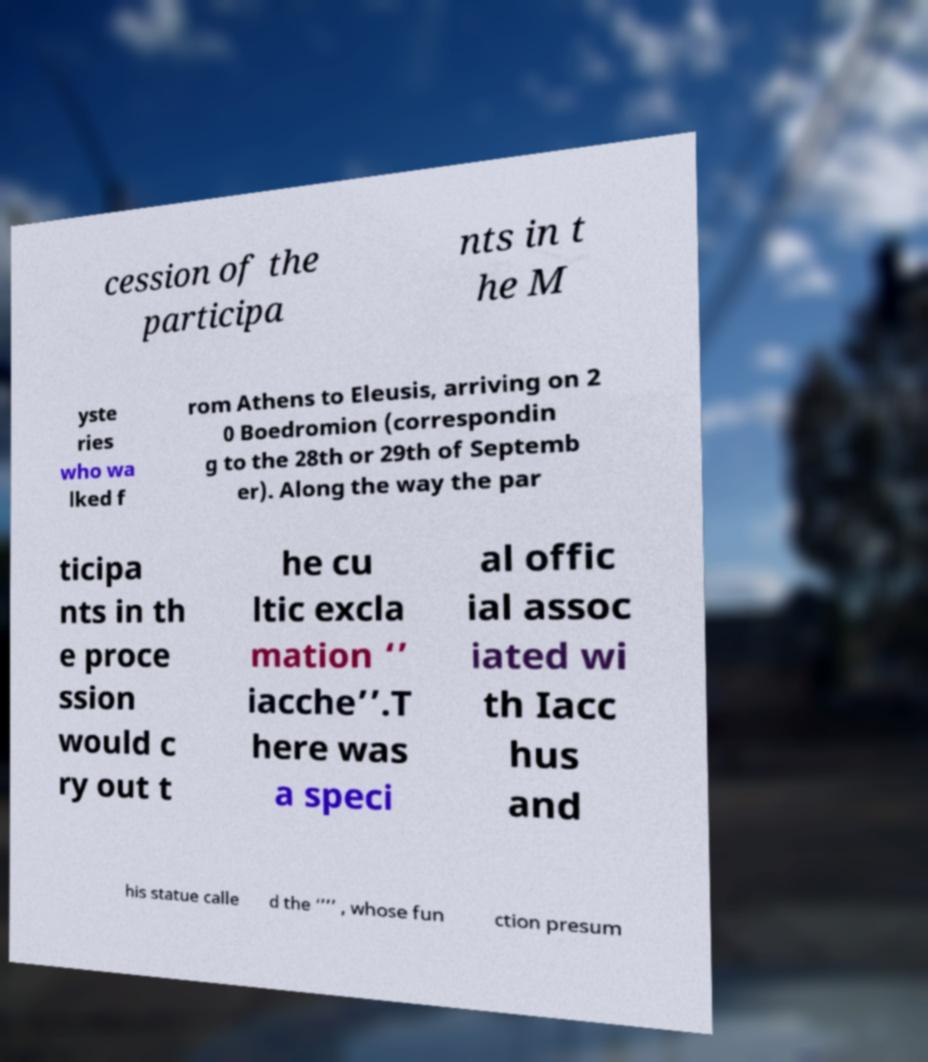What messages or text are displayed in this image? I need them in a readable, typed format. cession of the participa nts in t he M yste ries who wa lked f rom Athens to Eleusis, arriving on 2 0 Boedromion (correspondin g to the 28th or 29th of Septemb er). Along the way the par ticipa nts in th e proce ssion would c ry out t he cu ltic excla mation ‘’ iacche’’.T here was a speci al offic ial assoc iated wi th Iacc hus and his statue calle d the ‘’’’ , whose fun ction presum 